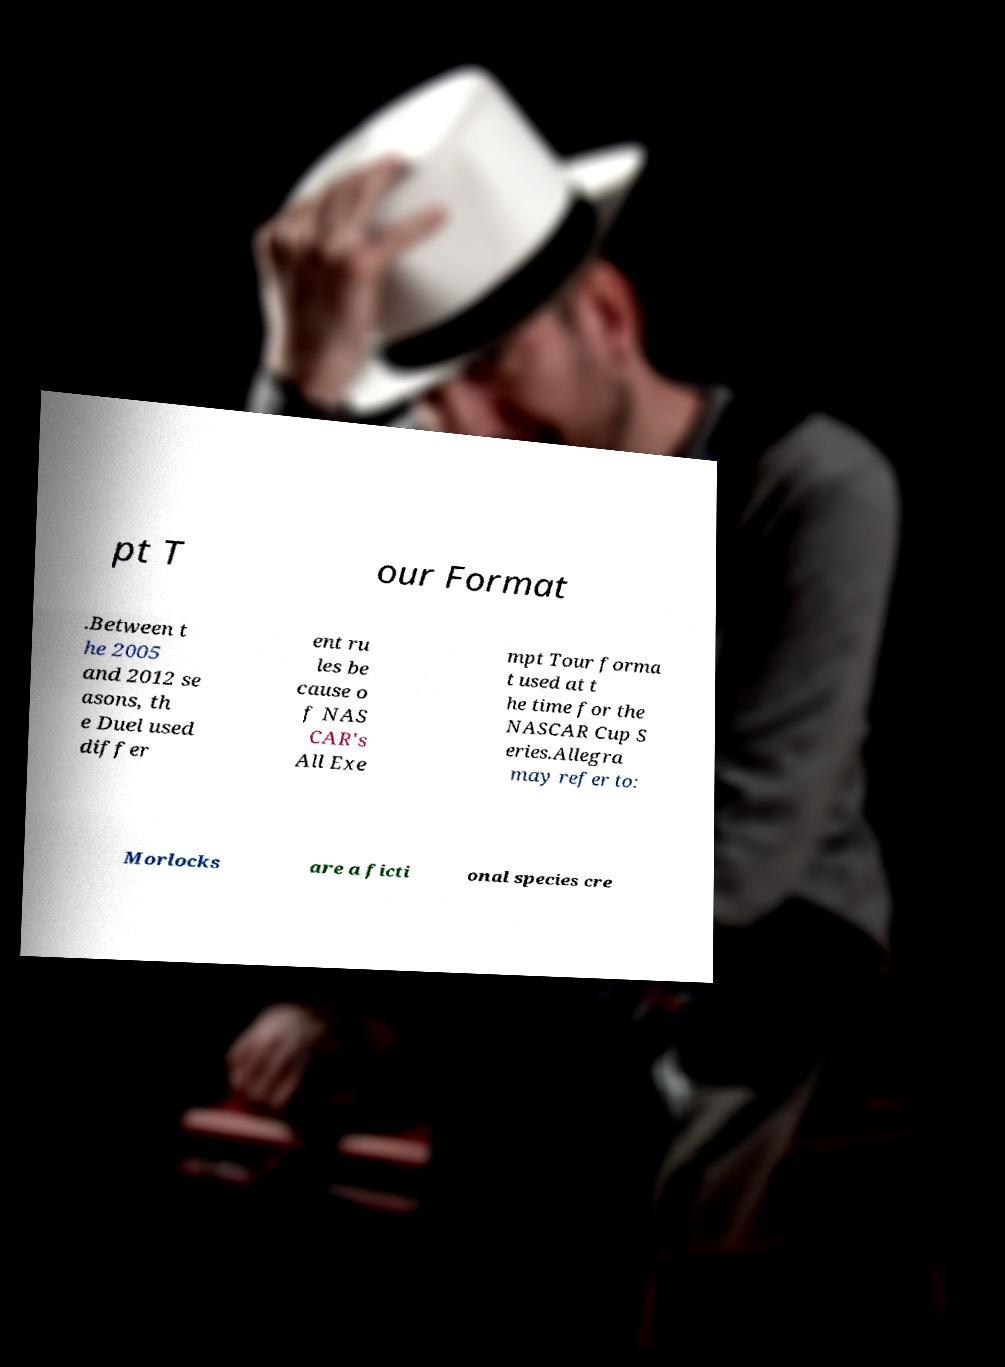For documentation purposes, I need the text within this image transcribed. Could you provide that? pt T our Format .Between t he 2005 and 2012 se asons, th e Duel used differ ent ru les be cause o f NAS CAR's All Exe mpt Tour forma t used at t he time for the NASCAR Cup S eries.Allegra may refer to: Morlocks are a ficti onal species cre 